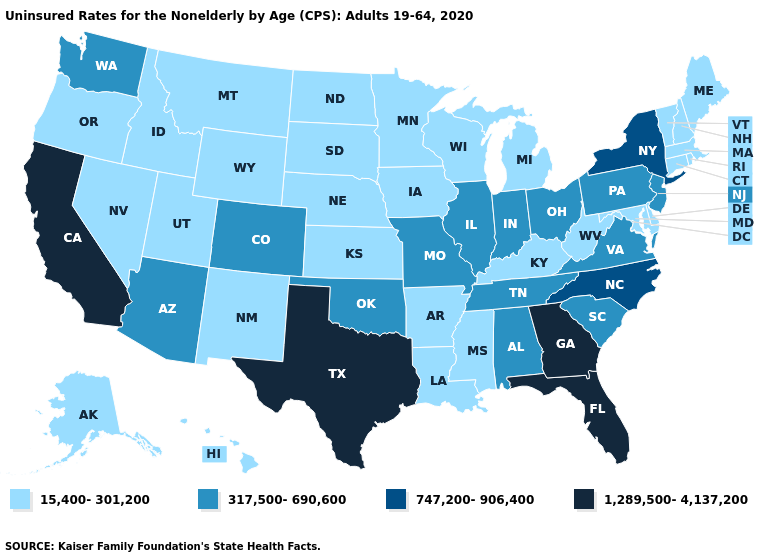Which states hav the highest value in the Northeast?
Keep it brief. New York. What is the value of Massachusetts?
Answer briefly. 15,400-301,200. Does California have the highest value in the USA?
Answer briefly. Yes. Does Missouri have a lower value than Florida?
Be succinct. Yes. What is the value of Missouri?
Keep it brief. 317,500-690,600. What is the highest value in states that border Ohio?
Write a very short answer. 317,500-690,600. Among the states that border Connecticut , does New York have the lowest value?
Give a very brief answer. No. Does Indiana have a lower value than New Hampshire?
Concise answer only. No. What is the value of Indiana?
Be succinct. 317,500-690,600. Among the states that border Pennsylvania , which have the highest value?
Answer briefly. New York. What is the value of North Carolina?
Answer briefly. 747,200-906,400. Does the map have missing data?
Give a very brief answer. No. What is the highest value in the USA?
Write a very short answer. 1,289,500-4,137,200. What is the value of Georgia?
Be succinct. 1,289,500-4,137,200. What is the highest value in states that border Louisiana?
Write a very short answer. 1,289,500-4,137,200. 